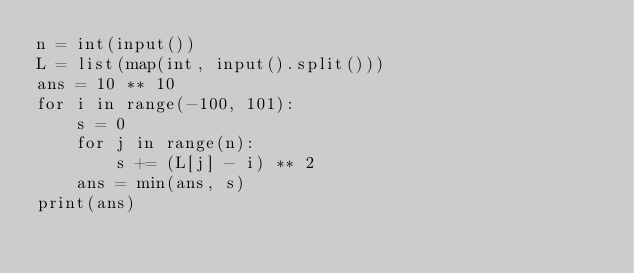Convert code to text. <code><loc_0><loc_0><loc_500><loc_500><_Python_>n = int(input())
L = list(map(int, input().split()))
ans = 10 ** 10
for i in range(-100, 101):
    s = 0
    for j in range(n):
        s += (L[j] - i) ** 2
    ans = min(ans, s)
print(ans)
</code> 